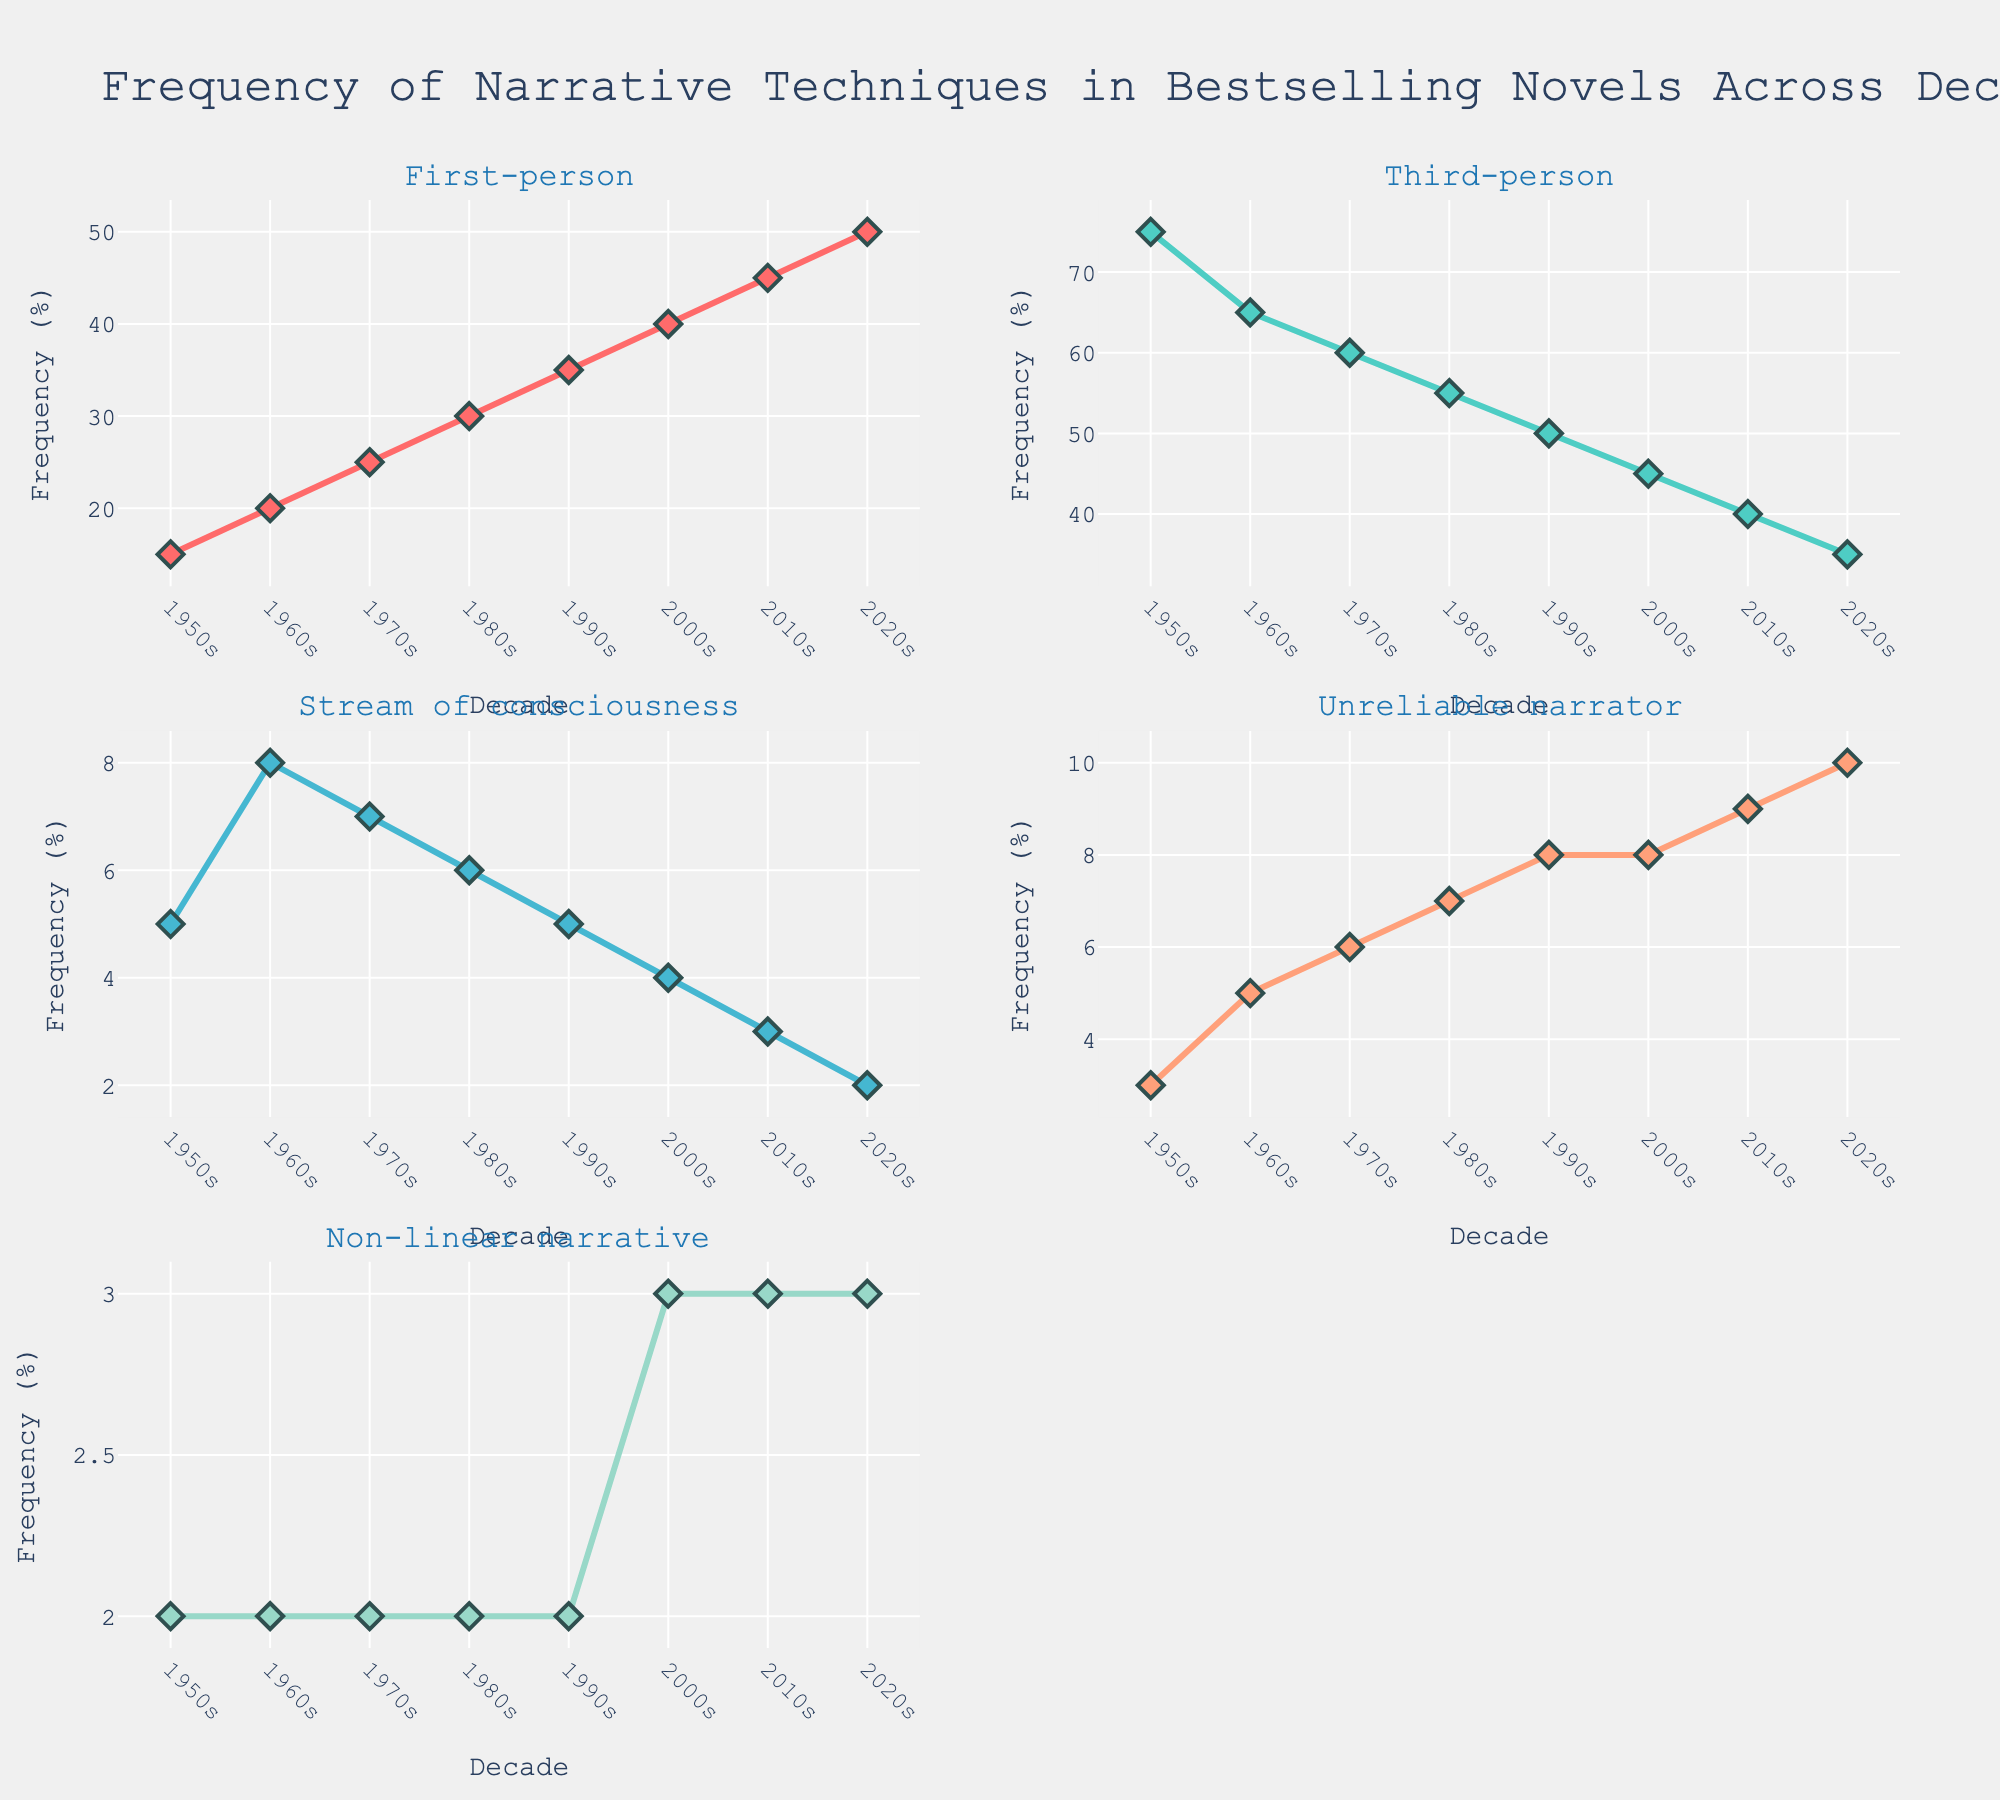What is the title of the figure? The title can be seen at the top center of the figure. It reads, "Frequency of Narrative Techniques in Bestselling Novels Across Decades."
Answer: Frequency of Narrative Techniques in Bestselling Novels Across Decades Which narrative technique shows a constant frequency from the 1950s to the 2020s? By examining each subplot, we see that the "Non-linear narrative" line remains flat at 2% and 3% across the decades.
Answer: Non-linear narrative What decade has the highest frequency for the "First-person" narrative? Look at the "First-person" subplot, where it peaks in the 2020s at 50%.
Answer: 2020s Between "Third-person" and "Stream of consciousness," which narrative technique showed a higher frequency in the 1970s? By comparing the lines in their respective subplots for the 1970s, "Third-person" has a frequency of 60%, while "Stream of consciousness" is at 7%. Therefore, "Third-person" is higher.
Answer: Third-person Calculate the average frequency of "Unreliable narrator" across all decades. The average is calculated by summing the "Unreliable narrator" frequencies: (3 + 5 + 6 + 7 + 8 + 8 + 9 + 10) = 56, then dividing by the number of decades, 56/8 = 7.
Answer: 7 How did the frequency of the "Third-person" narrative change from the 1950s to the 2020s? Look at the "Third-person" subplot; it starts at 75% in the 1950s and declines to 35% in the 2020s. The frequency has decreased.
Answer: Decreased Which decade shows the lowest frequency for "Non-linear narrative"? The subplot for "Non-linear narrative" shows the lowest frequency of 2% across the 1950s, 1960s, 1970s, 1980s, and 1990s. Therefore, any of these decades can be accepted.
Answer: 1950s (Also acceptable: 1960s, 1970s, 1980s, 1990s) Which narrative technique exhibited the most consistent increase in frequency from the 1950s to the 2020s? "First-person" subplot shows a steady increase, from 15% in the 1950s to 50% in the 2020s.
Answer: First-person Compare the frequencies of "Stream of consciousness" and "Unreliable narrator" in the 1990s. Which one was higher and by how much? In their respective subplots for the 1990s, "Stream of consciousness" is at 5%, and "Unreliable narrator" is at 8%. The frequency of "Unreliable narrator" is higher by 3%.
Answer: Unreliable narrator by 3% What is the trend for "Stream of consciousness" from the 1950s to the 2020s? The "Stream of consciousness" subplot shows a decline from 5% in the 1950s to 2% in the 2020s, with some fluctuations in between.
Answer: Decreasing 